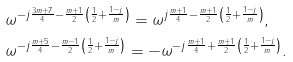Convert formula to latex. <formula><loc_0><loc_0><loc_500><loc_500>& \omega ^ { - j \frac { 3 m + 7 } { 4 } - \frac { m + 1 } { 2 } \left ( \frac { 1 } { 2 } + \frac { 1 - j } { m } \right ) } = \omega ^ { j \frac { m + 1 } { 4 } - \frac { m + 1 } { 2 } \left ( \frac { 1 } { 2 } + \frac { 1 - j } { m } \right ) } , \\ & \omega ^ { - j \frac { m + 5 } { 4 } - \frac { m - 1 } { 2 } \left ( \frac { 1 } { 2 } + \frac { 1 - j } { m } \right ) } = - \omega ^ { - j \frac { m + 1 } { 4 } + \frac { m + 1 } { 2 } \left ( \frac { 1 } { 2 } + \frac { 1 - j } { m } \right ) } .</formula> 